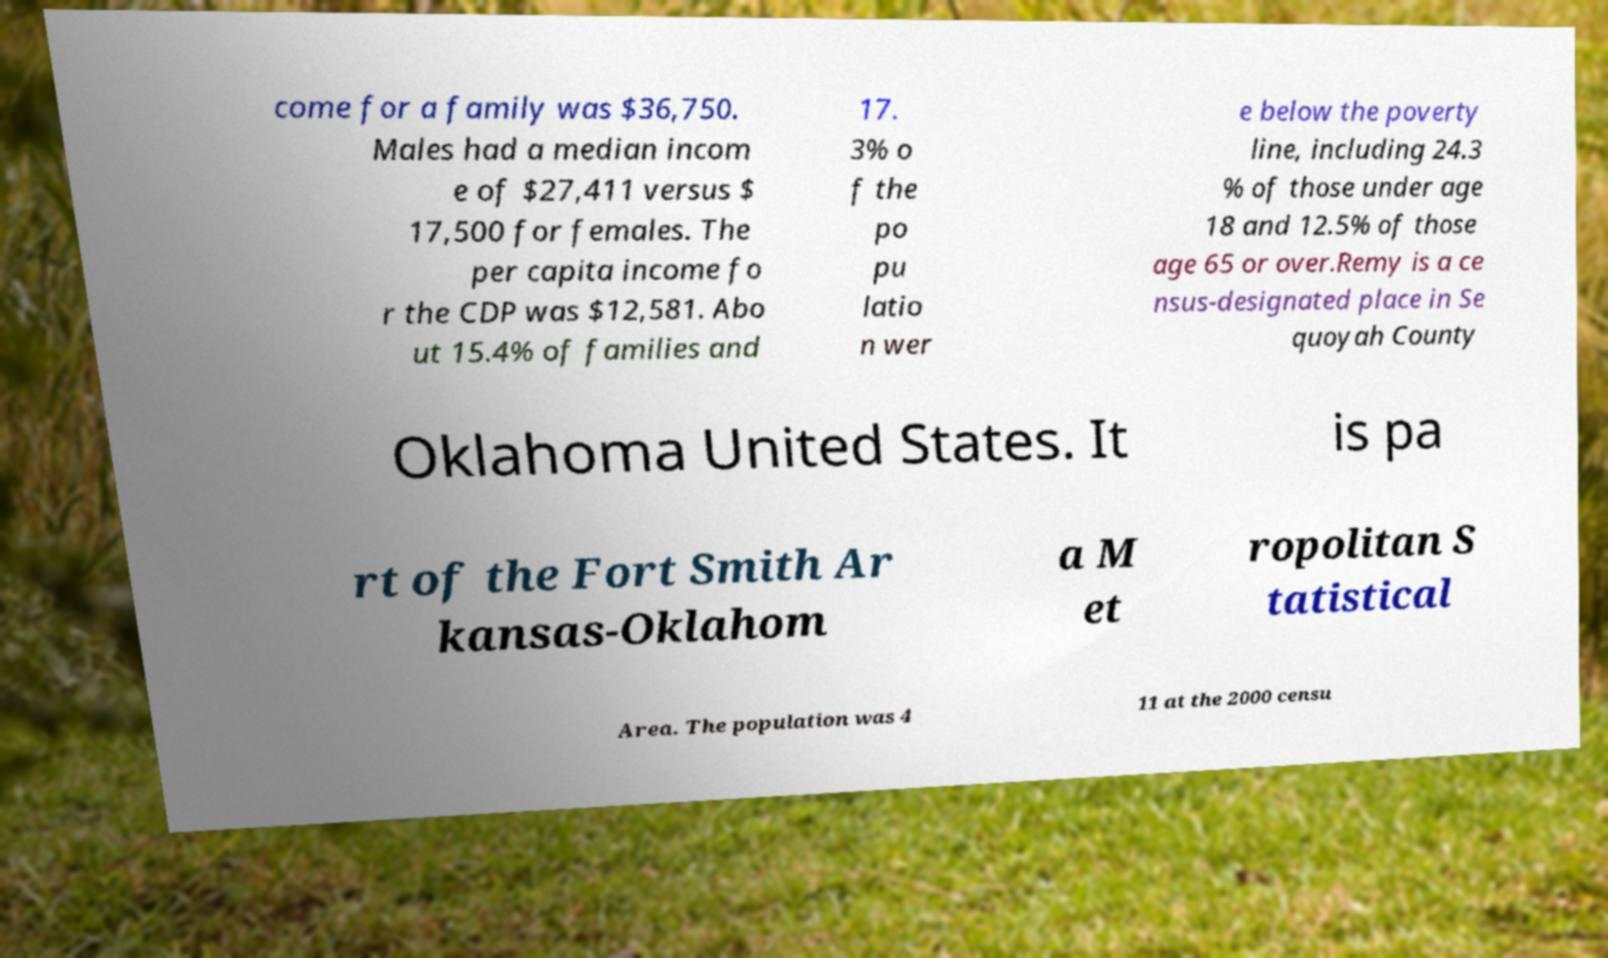Please read and relay the text visible in this image. What does it say? come for a family was $36,750. Males had a median incom e of $27,411 versus $ 17,500 for females. The per capita income fo r the CDP was $12,581. Abo ut 15.4% of families and 17. 3% o f the po pu latio n wer e below the poverty line, including 24.3 % of those under age 18 and 12.5% of those age 65 or over.Remy is a ce nsus-designated place in Se quoyah County Oklahoma United States. It is pa rt of the Fort Smith Ar kansas-Oklahom a M et ropolitan S tatistical Area. The population was 4 11 at the 2000 censu 